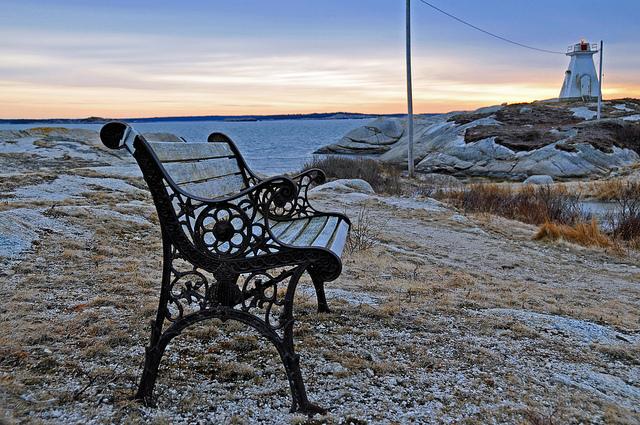Is the bench facing the lighthouse?
Write a very short answer. No. What is the bench made of?
Quick response, please. Metal and wood. Is there snow on the ground?
Write a very short answer. Yes. 